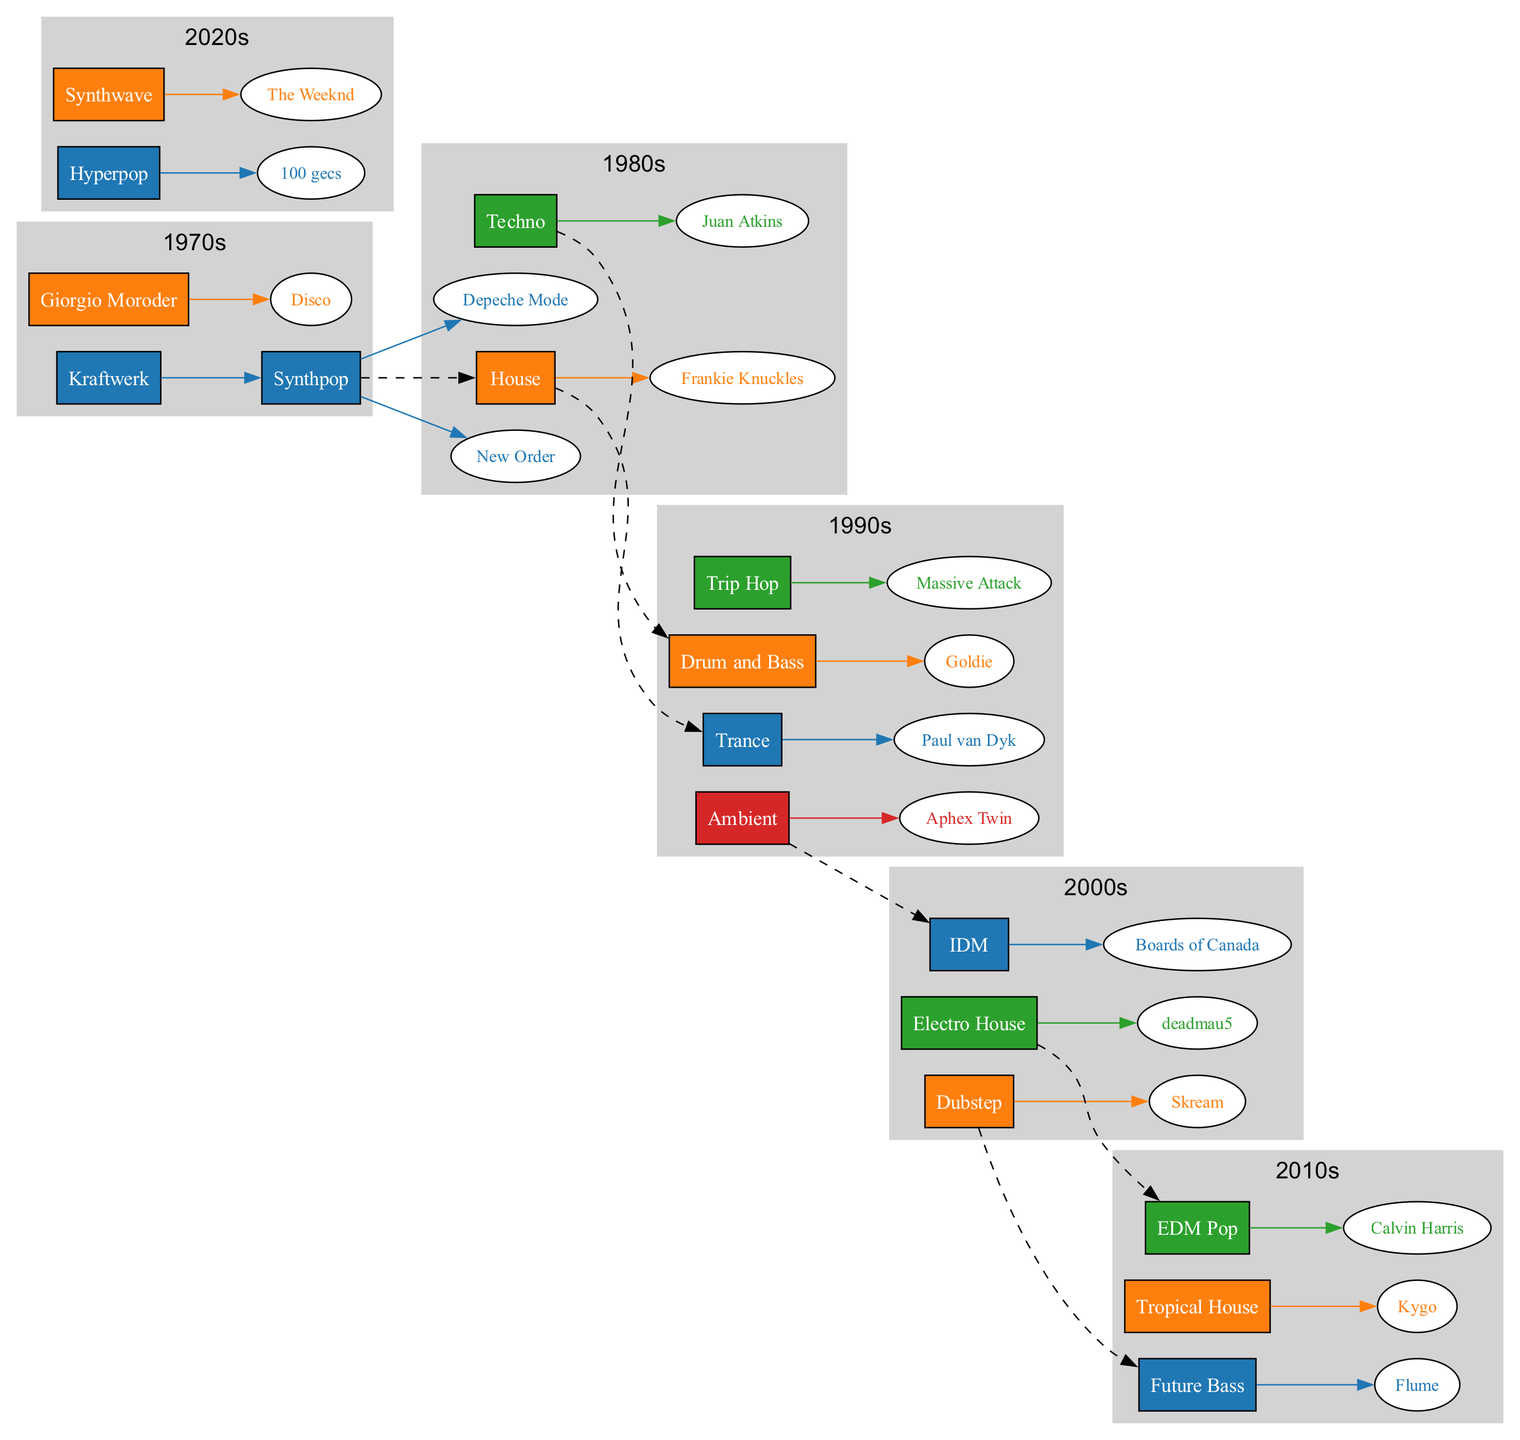What genre did Kraftwerk contribute to in the 1970s? According to the diagram, Kraftwerk is associated with the genre Synthpop, which is listed directly under the 1970s section.
Answer: Synthpop Which artist is associated with House music from the 1980s? The diagram clearly shows that the artist Frankie Knuckles is linked to the genre House, indented under the 1980s decade.
Answer: Frankie Knuckles How many genres were listed in the 1990s? By counting the nodes under the 1990s section, there are four genres: Trance, Drum and Bass, Trip Hop, and Ambient.
Answer: 4 What is the relationship between Dubstep and Future Bass? The diagram illustrates a dashed connection (indicating a stylistic influence) from Dubstep in the 2000s to Future Bass in the 2010s, showing that Dubstep influenced the development of Future Bass.
Answer: Dashed connection Which genre is a subgenre of Synthpop according to the diagram? The diagram connects Synthpop to House with a dashed line, indicating that House is a subgenre derived from Synthpop, showing the evolutionary link between them.
Answer: House What is the earliest genre in the diagram? The first node in the diagram is Synthpop, listed under the 1970s, making it the earliest genre in the evolution of electronic music depicted here.
Answer: Synthpop Which artist is associated with Ambient music? The diagram identifies Aphex Twin as the artist linked to the genre Ambient, which is placed under the 1990s section.
Answer: Aphex Twin What decade saw the emergence of Hyperpop? The diagram shows Hyperpop is rooted in the 2020s, as it is placed directly under that decade.
Answer: 2020s Which two genres form a dashed connection in the 2000s? The diagram indicates a dashed connection between Dubstep and Future Bass, highlighting a stylistic influence from Dubstep on Future Bass development during the 2000s.
Answer: Dubstep and Future Bass 